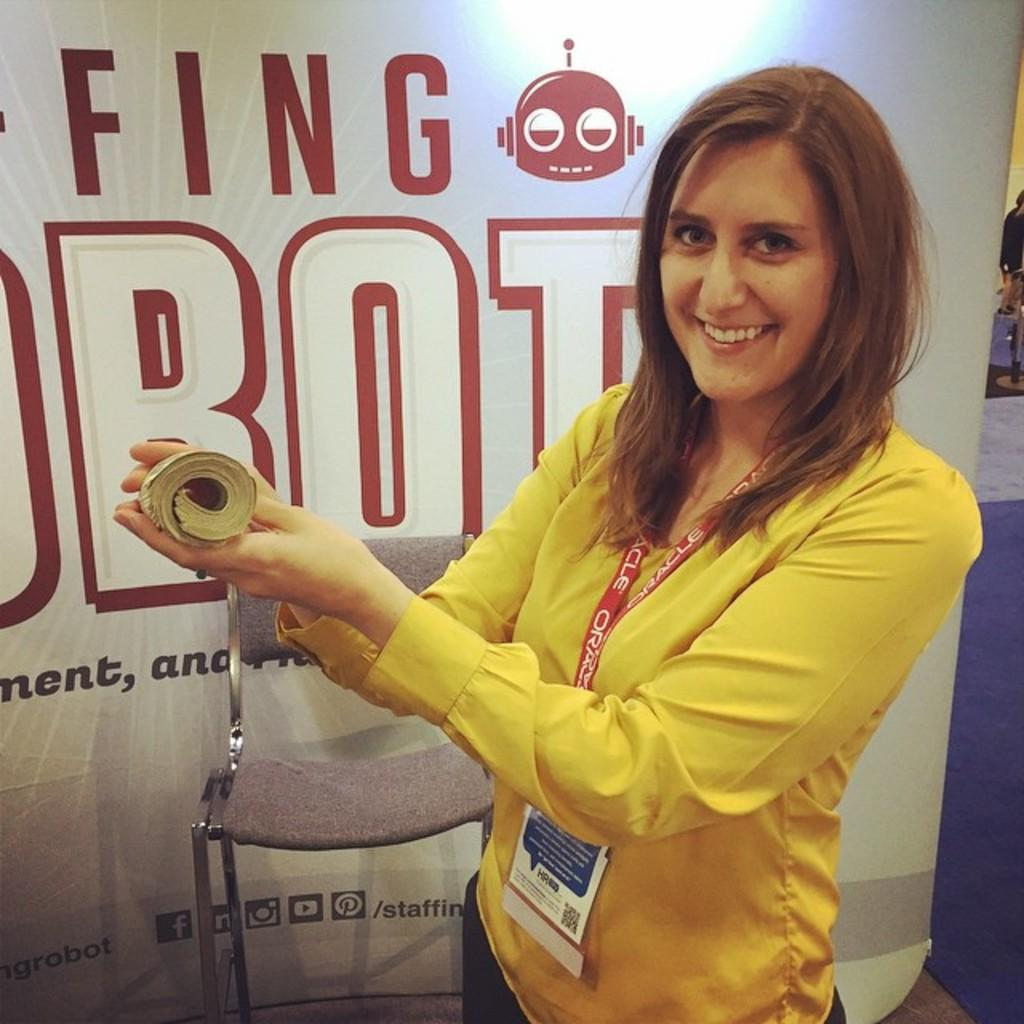Who is present in the image? There is a woman in the image. What is the woman wearing? The woman is wearing a yellow shirt. Does the woman have any identification in the image? Yes, the woman has an ID card. What is the woman holding in her hand? The woman is holding a book in her hand. What can be seen in the background of the image? There is a chair and a banner in the background of the image. What type of wool can be seen on the rabbits in the image? There are no rabbits present in the image, and therefore no wool can be seen. Can you hear the thunder in the image? There is no mention of thunder or any sound in the image, so it cannot be heard. 